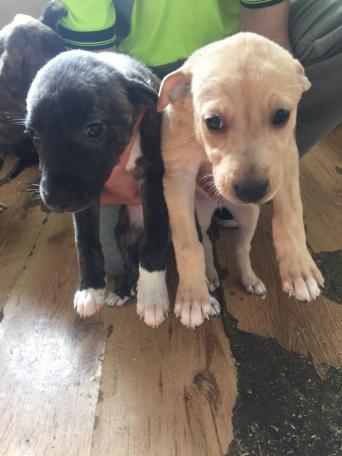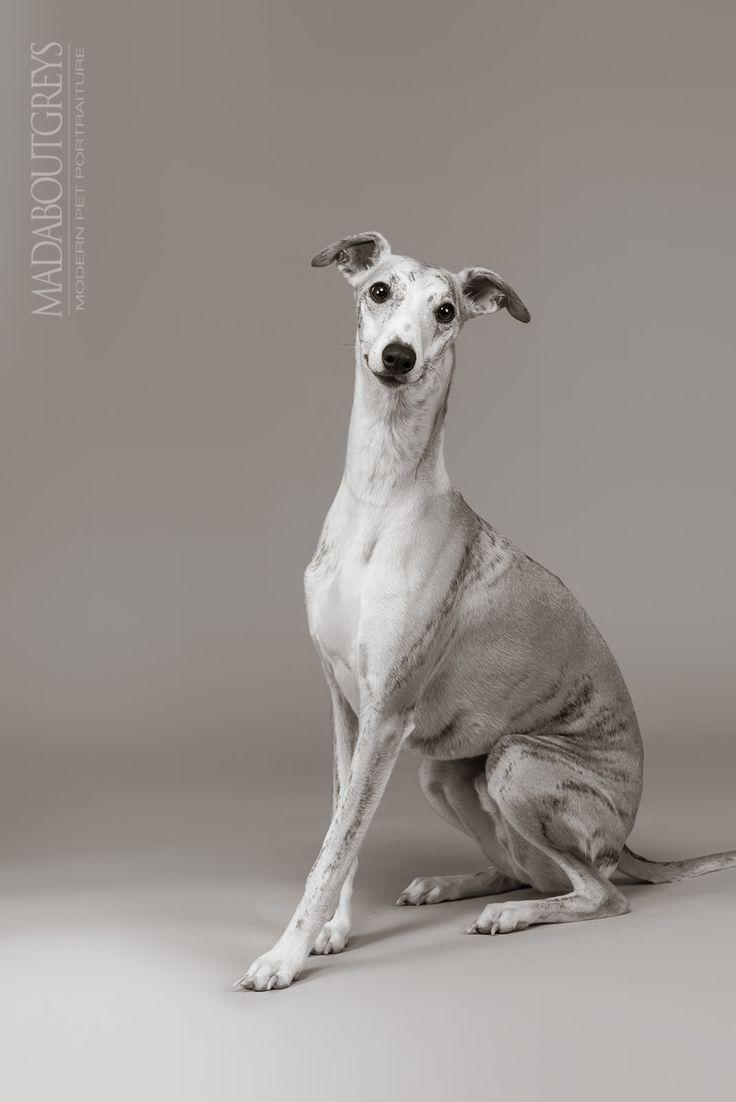The first image is the image on the left, the second image is the image on the right. For the images displayed, is the sentence "A dog with a necklace is lying down in one of the images." factually correct? Answer yes or no. No. The first image is the image on the left, the second image is the image on the right. Examine the images to the left and right. Is the description "An image shows a hound wearing a pearl-look necklace." accurate? Answer yes or no. No. 